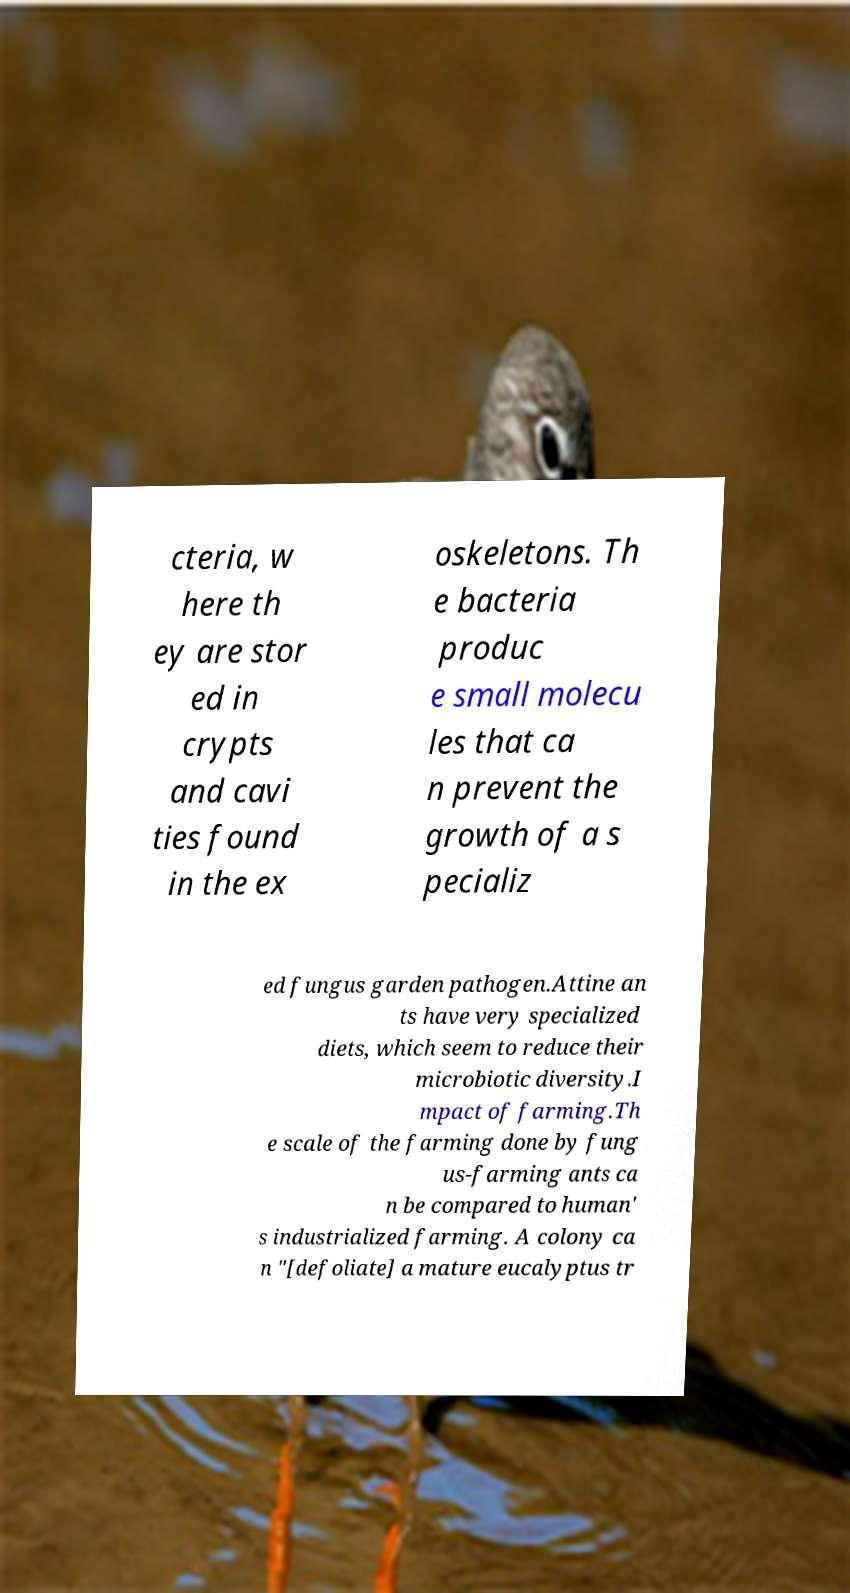I need the written content from this picture converted into text. Can you do that? cteria, w here th ey are stor ed in crypts and cavi ties found in the ex oskeletons. Th e bacteria produc e small molecu les that ca n prevent the growth of a s pecializ ed fungus garden pathogen.Attine an ts have very specialized diets, which seem to reduce their microbiotic diversity.I mpact of farming.Th e scale of the farming done by fung us-farming ants ca n be compared to human' s industrialized farming. A colony ca n "[defoliate] a mature eucalyptus tr 